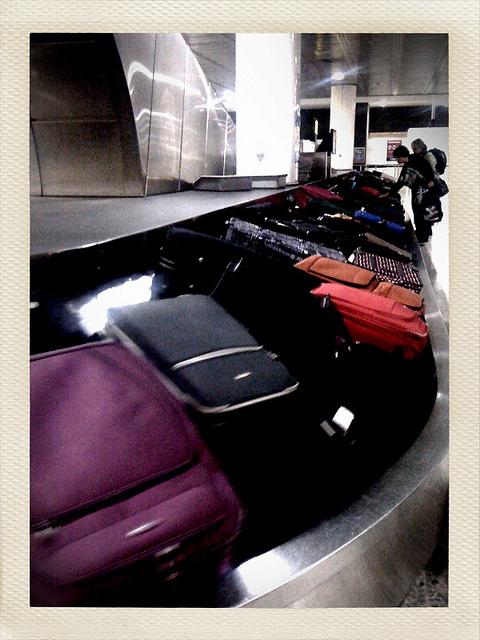What kind of facility is this?
Concise answer only. Airport. How many blue suitcases are there?
Write a very short answer. 1. How many people are visible?
Be succinct. 2. 